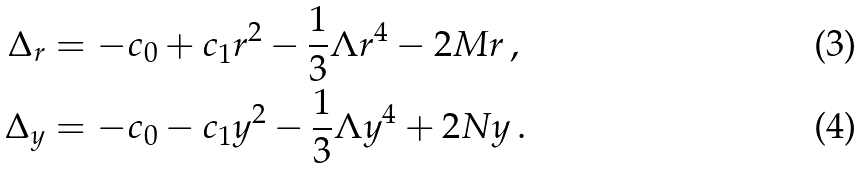Convert formula to latex. <formula><loc_0><loc_0><loc_500><loc_500>\Delta _ { r } & = - c _ { 0 } + c _ { 1 } r ^ { 2 } - \frac { 1 } { 3 } \Lambda r ^ { 4 } - 2 M r \, , \\ \Delta _ { y } & = - c _ { 0 } - c _ { 1 } y ^ { 2 } - \frac { 1 } { 3 } \Lambda y ^ { 4 } + 2 N y \, .</formula> 